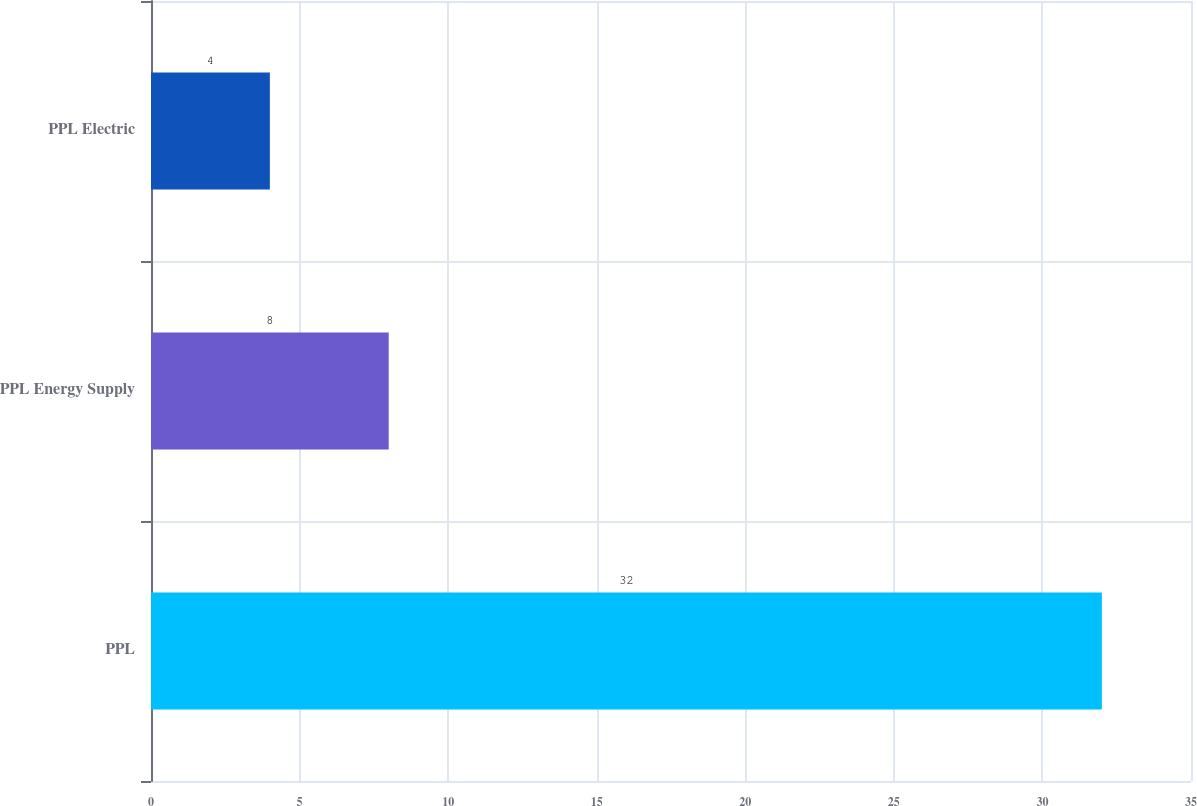Convert chart to OTSL. <chart><loc_0><loc_0><loc_500><loc_500><bar_chart><fcel>PPL<fcel>PPL Energy Supply<fcel>PPL Electric<nl><fcel>32<fcel>8<fcel>4<nl></chart> 